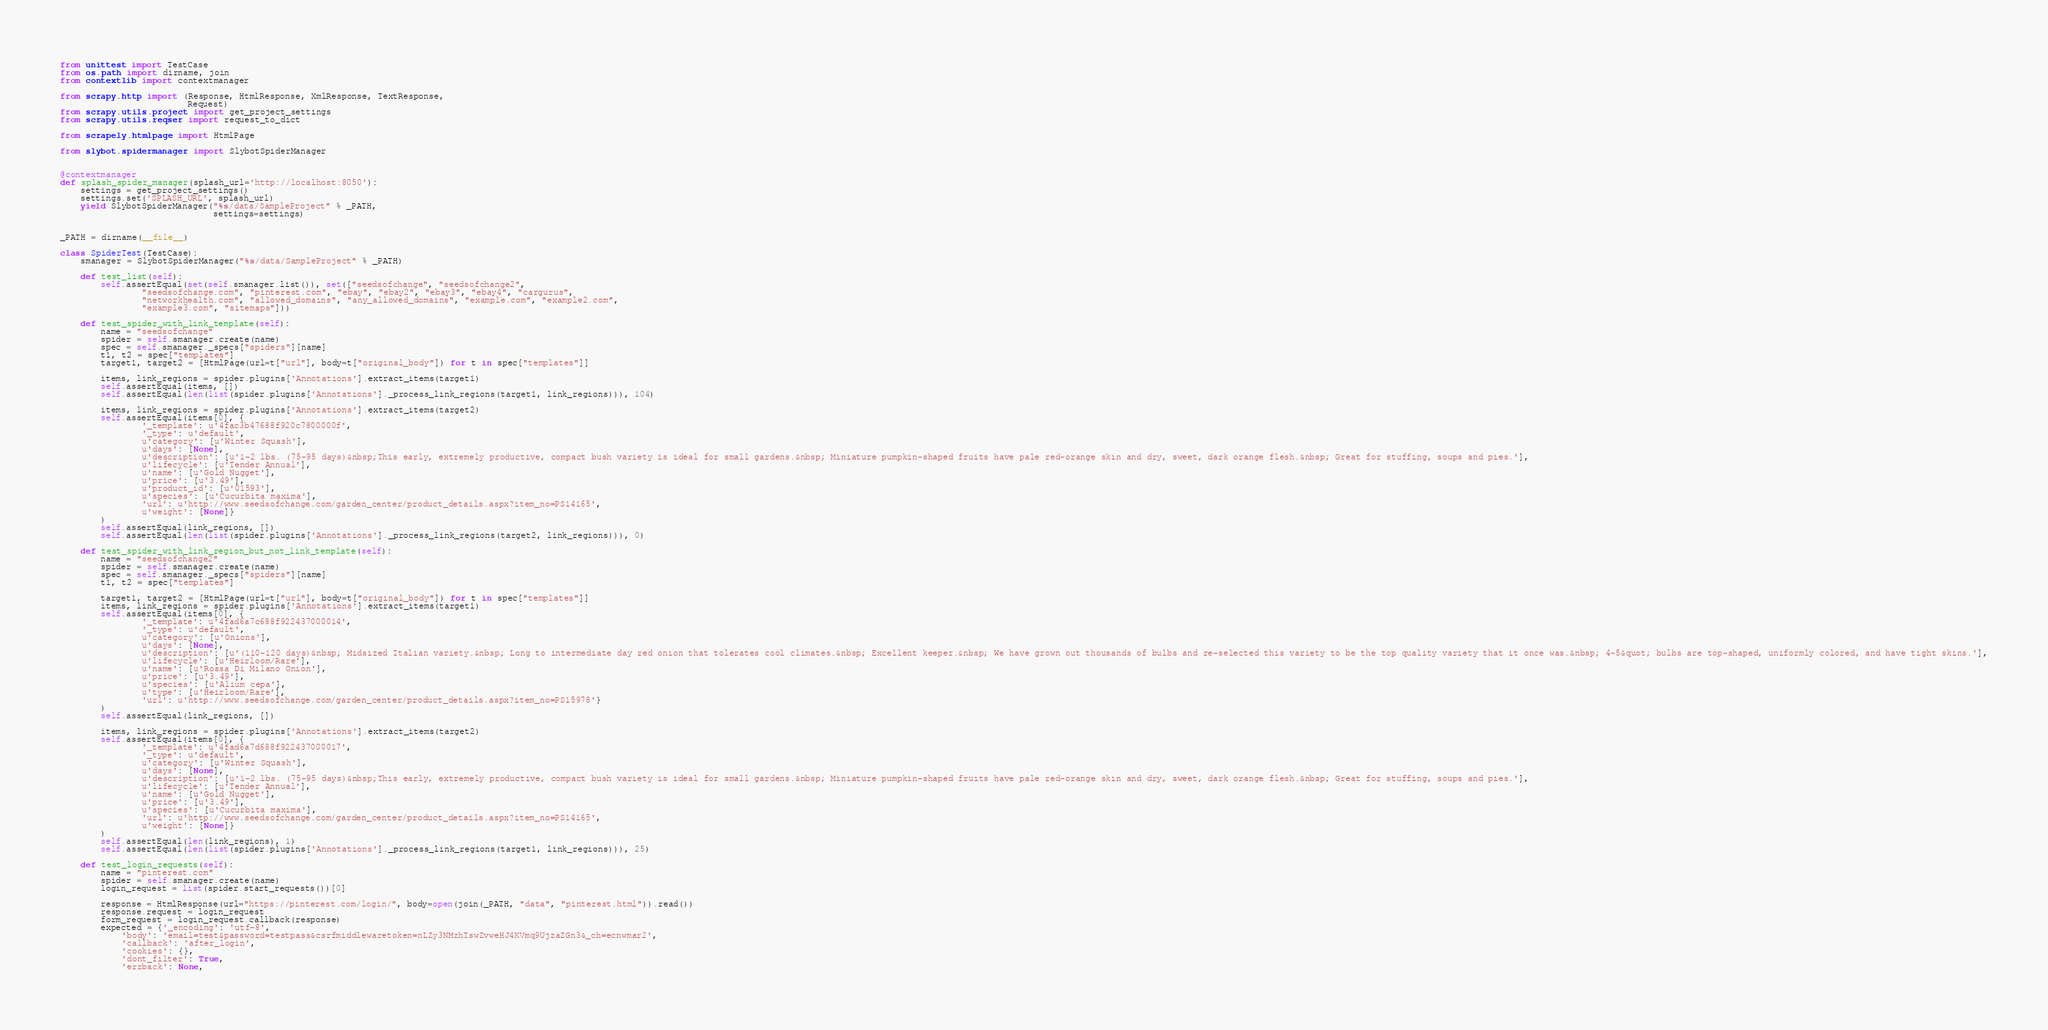<code> <loc_0><loc_0><loc_500><loc_500><_Python_>from unittest import TestCase
from os.path import dirname, join
from contextlib import contextmanager

from scrapy.http import (Response, HtmlResponse, XmlResponse, TextResponse,
                         Request)
from scrapy.utils.project import get_project_settings
from scrapy.utils.reqser import request_to_dict

from scrapely.htmlpage import HtmlPage

from slybot.spidermanager import SlybotSpiderManager


@contextmanager
def splash_spider_manager(splash_url='http://localhost:8050'):
    settings = get_project_settings()
    settings.set('SPLASH_URL', splash_url)
    yield SlybotSpiderManager("%s/data/SampleProject" % _PATH,
                              settings=settings)


_PATH = dirname(__file__)

class SpiderTest(TestCase):
    smanager = SlybotSpiderManager("%s/data/SampleProject" % _PATH)

    def test_list(self):
        self.assertEqual(set(self.smanager.list()), set(["seedsofchange", "seedsofchange2",
                "seedsofchange.com", "pinterest.com", "ebay", "ebay2", "ebay3", "ebay4", "cargurus",
                "networkhealth.com", "allowed_domains", "any_allowed_domains", "example.com", "example2.com",
                "example3.com", "sitemaps"]))

    def test_spider_with_link_template(self):
        name = "seedsofchange"
        spider = self.smanager.create(name)
        spec = self.smanager._specs["spiders"][name]
        t1, t2 = spec["templates"]
        target1, target2 = [HtmlPage(url=t["url"], body=t["original_body"]) for t in spec["templates"]]

        items, link_regions = spider.plugins['Annotations'].extract_items(target1)
        self.assertEqual(items, [])
        self.assertEqual(len(list(spider.plugins['Annotations']._process_link_regions(target1, link_regions))), 104)

        items, link_regions = spider.plugins['Annotations'].extract_items(target2)
        self.assertEqual(items[0], {
                '_template': u'4fac3b47688f920c7800000f',
                '_type': u'default',
                u'category': [u'Winter Squash'],
                u'days': [None],
                u'description': [u'1-2 lbs. (75-95 days)&nbsp;This early, extremely productive, compact bush variety is ideal for small gardens.&nbsp; Miniature pumpkin-shaped fruits have pale red-orange skin and dry, sweet, dark orange flesh.&nbsp; Great for stuffing, soups and pies.'],
                u'lifecycle': [u'Tender Annual'],
                u'name': [u'Gold Nugget'],
                u'price': [u'3.49'],
                u'product_id': [u'01593'],
                u'species': [u'Cucurbita maxima'],
                'url': u'http://www.seedsofchange.com/garden_center/product_details.aspx?item_no=PS14165',
                u'weight': [None]}
        )
        self.assertEqual(link_regions, [])
        self.assertEqual(len(list(spider.plugins['Annotations']._process_link_regions(target2, link_regions))), 0)

    def test_spider_with_link_region_but_not_link_template(self):
        name = "seedsofchange2"
        spider = self.smanager.create(name)
        spec = self.smanager._specs["spiders"][name]
        t1, t2 = spec["templates"]

        target1, target2 = [HtmlPage(url=t["url"], body=t["original_body"]) for t in spec["templates"]]
        items, link_regions = spider.plugins['Annotations'].extract_items(target1)
        self.assertEqual(items[0], {
                '_template': u'4fad6a7c688f922437000014',
                '_type': u'default',
                u'category': [u'Onions'],
                u'days': [None],
                u'description': [u'(110-120 days)&nbsp; Midsized Italian variety.&nbsp; Long to intermediate day red onion that tolerates cool climates.&nbsp; Excellent keeper.&nbsp; We have grown out thousands of bulbs and re-selected this variety to be the top quality variety that it once was.&nbsp; 4-5&quot; bulbs are top-shaped, uniformly colored, and have tight skins.'],
                u'lifecycle': [u'Heirloom/Rare'],
                u'name': [u'Rossa Di Milano Onion'],
                u'price': [u'3.49'],
                u'species': [u'Alium cepa'],
                u'type': [u'Heirloom/Rare'],
                'url': u'http://www.seedsofchange.com/garden_center/product_details.aspx?item_no=PS15978'}
        )
        self.assertEqual(link_regions, [])

        items, link_regions = spider.plugins['Annotations'].extract_items(target2)
        self.assertEqual(items[0], {
                '_template': u'4fad6a7d688f922437000017',
                '_type': u'default',
                u'category': [u'Winter Squash'],
                u'days': [None],
                u'description': [u'1-2 lbs. (75-95 days)&nbsp;This early, extremely productive, compact bush variety is ideal for small gardens.&nbsp; Miniature pumpkin-shaped fruits have pale red-orange skin and dry, sweet, dark orange flesh.&nbsp; Great for stuffing, soups and pies.'],
                u'lifecycle': [u'Tender Annual'],
                u'name': [u'Gold Nugget'],
                u'price': [u'3.49'],
                u'species': [u'Cucurbita maxima'],
                'url': u'http://www.seedsofchange.com/garden_center/product_details.aspx?item_no=PS14165',
                u'weight': [None]}
        )
        self.assertEqual(len(link_regions), 1)
        self.assertEqual(len(list(spider.plugins['Annotations']._process_link_regions(target1, link_regions))), 25)

    def test_login_requests(self):
        name = "pinterest.com"
        spider = self.smanager.create(name)
        login_request = list(spider.start_requests())[0]

        response = HtmlResponse(url="https://pinterest.com/login/", body=open(join(_PATH, "data", "pinterest.html")).read())
        response.request = login_request
        form_request = login_request.callback(response)
        expected = {'_encoding': 'utf-8',
            'body': 'email=test&password=testpass&csrfmiddlewaretoken=nLZy3NMzhTswZvweHJ4KVmq9UjzaZGn3&_ch=ecnwmar2',
            'callback': 'after_login',
            'cookies': {},
            'dont_filter': True,
            'errback': None,</code> 